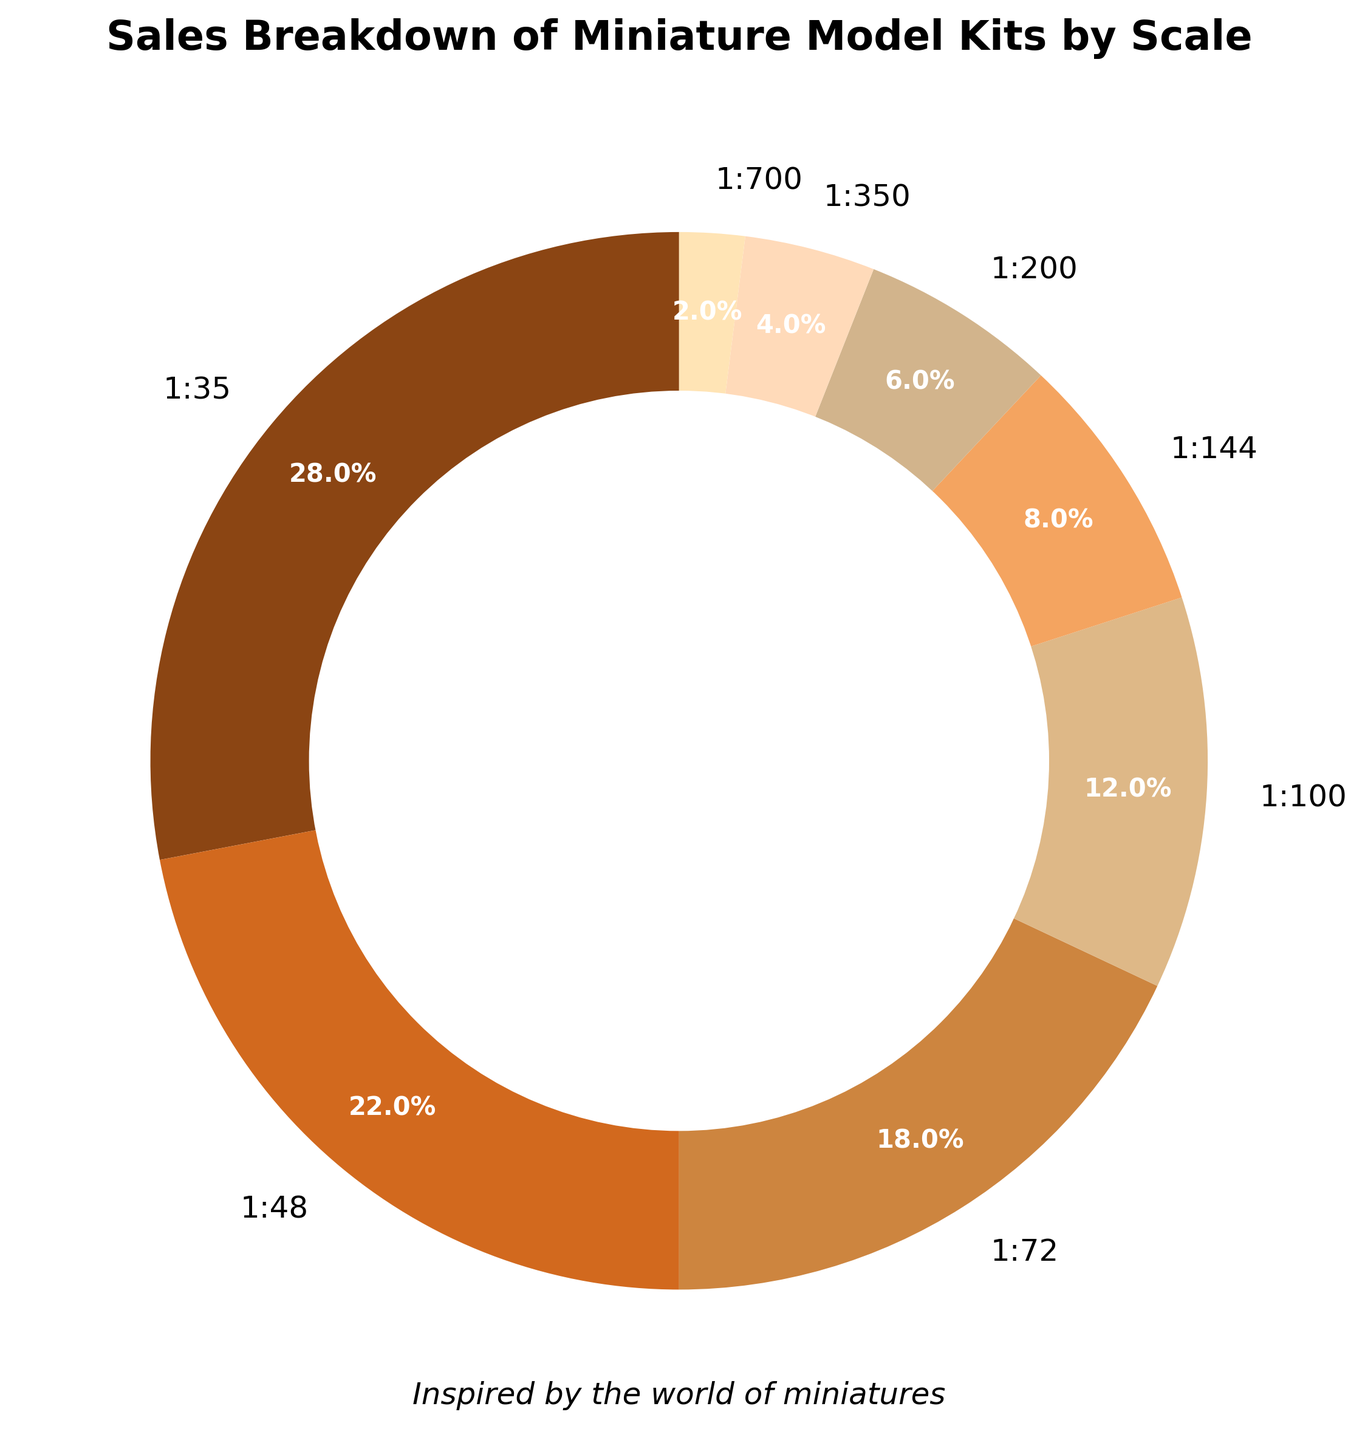What percentage of sales is attributed to scales 1:35, 1:48, and 1:72 combined? To find the combined percentage for scales 1:35, 1:48, and 1:72, sum their individual percentages: 28% + 22% + 18% = 68%.
Answer: 68% Which scale has the lowest percentage of sales? Identify the segment with the smallest portion; 1:700 has the lowest percentage at 2%.
Answer: 1:700 How much greater is the sales percentage of scale 1:35 compared to scale 1:100? Subtract the percentage of scale 1:100 from 1:35: 28% - 12% = 16%.
Answer: 16% Are the combined sales of scales 1:200, 1:350, and 1:700 greater than those of scale 1:72? Sum the percentages for scales 1:200, 1:350, and 1:700: 6% + 4% + 2% = 12%. Compare with scale 1:72 which is 18%. 12% < 18%, so they are not greater.
Answer: No What color represents scale 1:48 in the pie chart? Observe the color assigned to the section labeled 1:48; it is the second segment which is brownish.
Answer: Brownish If scales 1:100 and 1:144 are combined into a new percentile category, what would be the new combined percentage and would it be greater than scale 1:48? Add the percentages for scales 1:100 and 1:144: 12% + 8% = 20%. Compare this with scale 1:48 which is 22%. 20% < 22%, so it would be less.
Answer: 20%, No Which scale is represented by the darkest segment in the pie chart? Assess the visualization and find the darkest segment, which corresponds to 1:35.
Answer: 1:35 Among scales 1:72, 1:144, and 1:350, which has the highest sales percentage and what is the value? Compare the percentages for scales 1:72 (18%), 1:144 (8%), and 1:350 (4%). Scale 1:72 has the highest sales percentage.
Answer: 1:72, 18% What percentage of sales does scale 1:200 contribute? Identify the segment corresponding to scale 1:200 and read its percentage, which is 6%.
Answer: 6% What is the total sales percentage of scales less than 1:100? Sum the percentages for scales less than 1:100 (1:144, 1:200, 1:350, 1:700): 8% + 6% + 4% + 2% = 20%.
Answer: 20% 